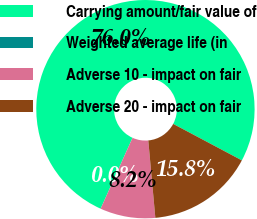Convert chart. <chart><loc_0><loc_0><loc_500><loc_500><pie_chart><fcel>Carrying amount/fair value of<fcel>Weighted average life (in<fcel>Adverse 10 - impact on fair<fcel>Adverse 20 - impact on fair<nl><fcel>76.04%<fcel>0.0%<fcel>8.18%<fcel>15.78%<nl></chart> 